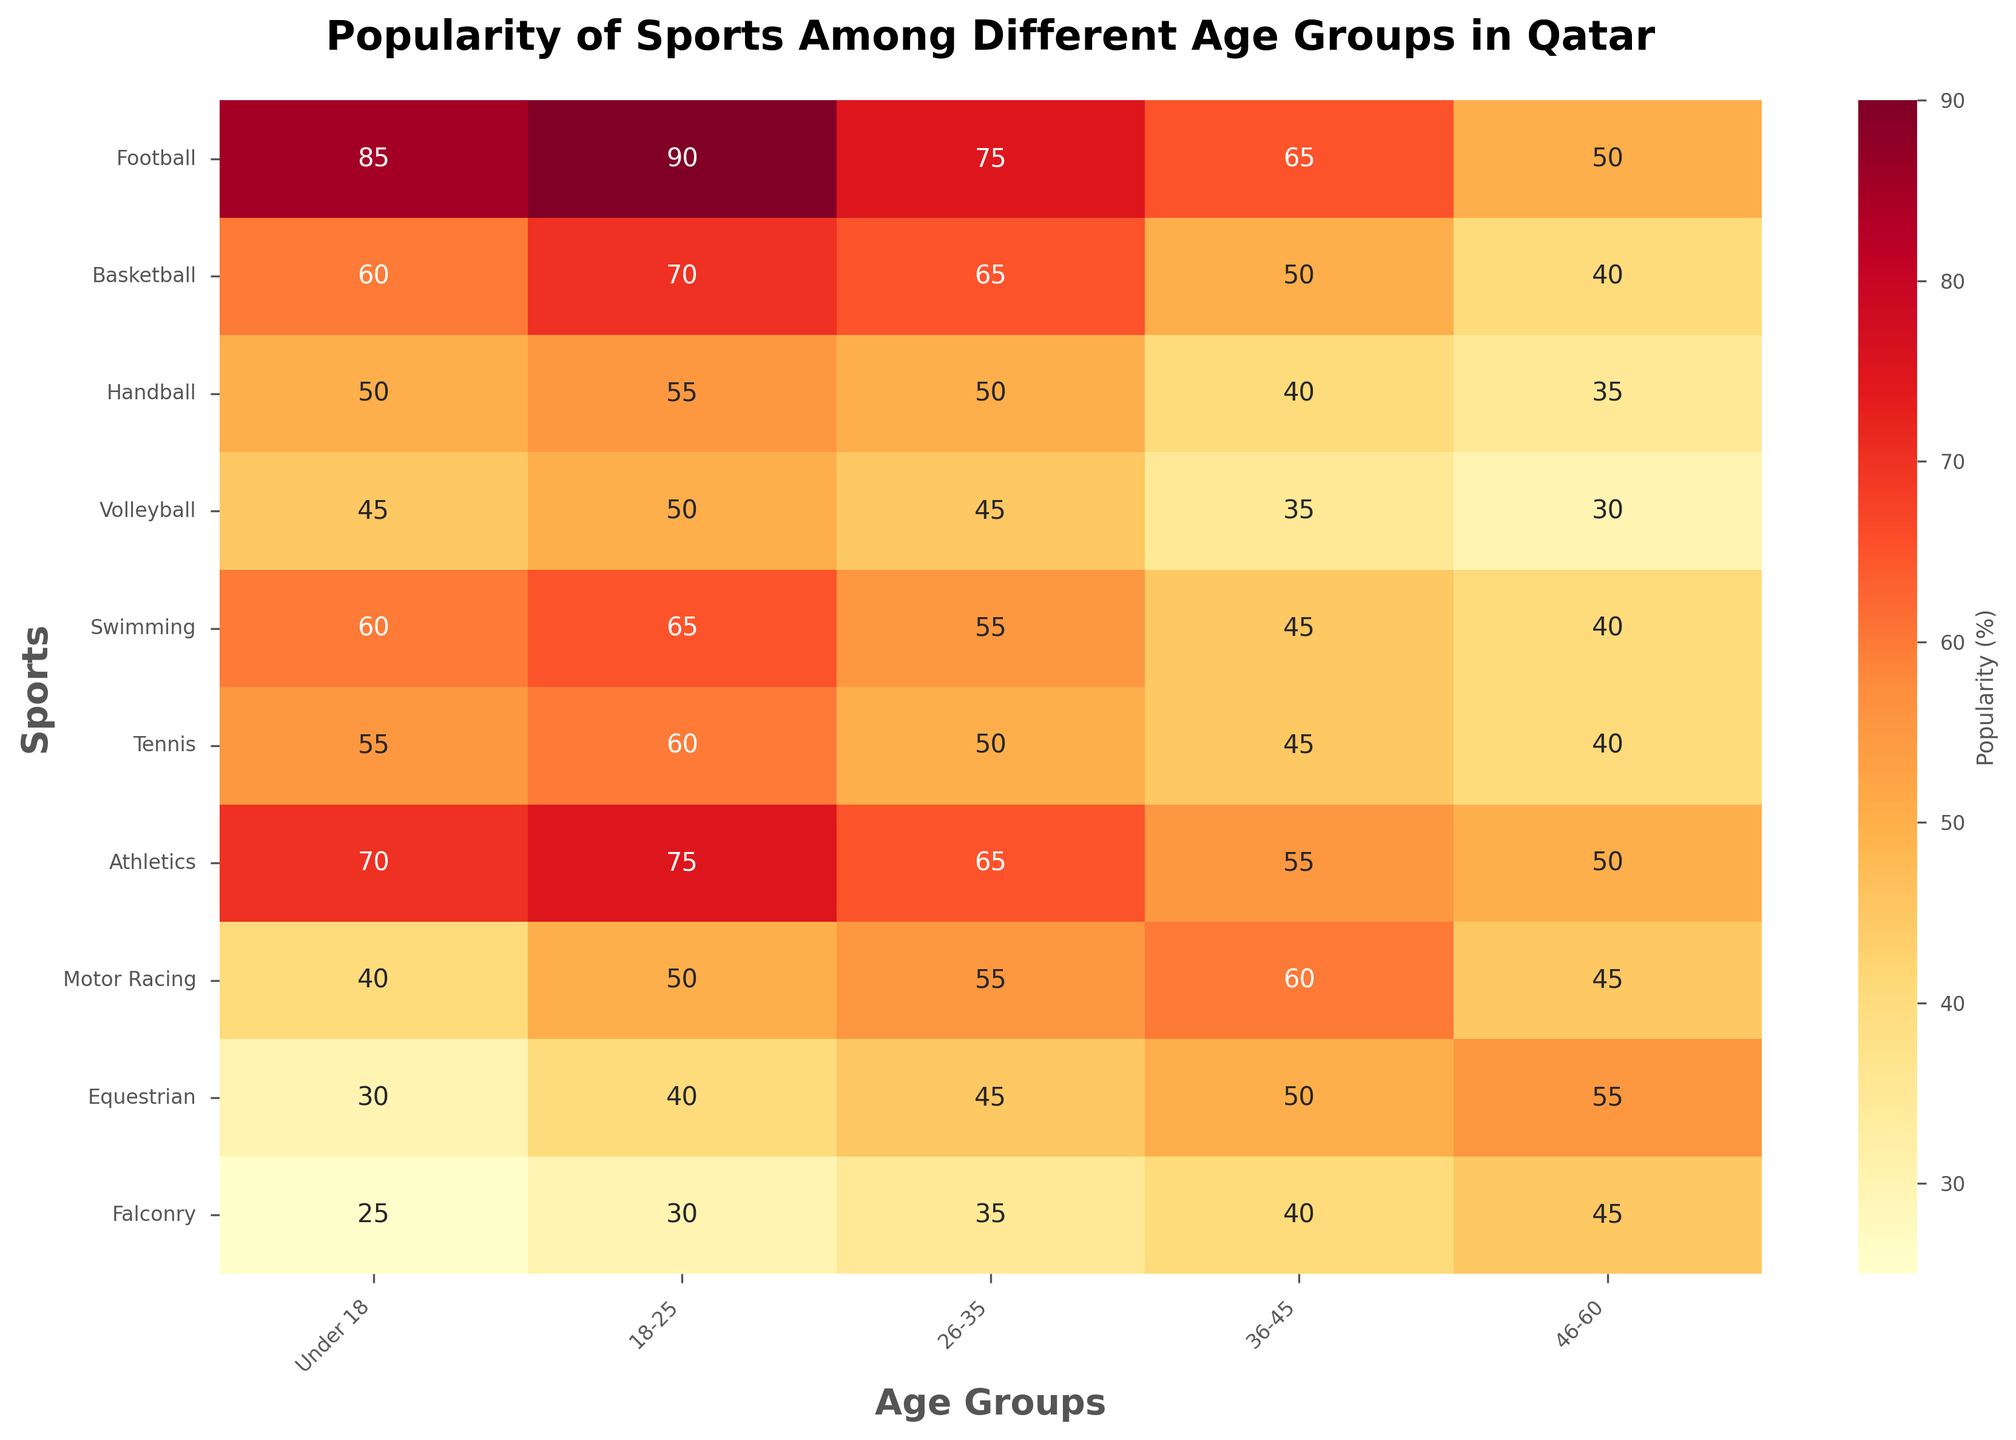Which sport is the most popular among the Under 18 age group? The heatmap shows popularity percentages for different sports by age groups. For the Under 18 age group, look for the highest value. Football has the highest value at 85.
Answer: Football What is the difference in popularity of Motor Racing between the 36-45 and Under 18 age groups? Identify the values for Motor Racing in the respective age groups from the heatmap: 60 for 36-45 and 40 for Under 18. The difference is 60 - 40.
Answer: 20 How does the popularity of Falconry change across the age groups? Observe the values for Falconry across all age groups in the heatmap: 25 (Under 18), 30 (18-25), 35 (26-35), 40 (36-45), and 45 (46-60). The popularity gradually increases as the age group increases.
Answer: Increases Which age group shows the lowest popularity for Tennis? Find the Tennis row and identify the lowest value across the age groups in the heatmap. The lowest value is 50, found in the 26-35 age group.
Answer: 26-35 What is the average popularity of Volleyball across all age groups? Sum the popularity values for Volleyball across all age groups and divide by the number of age groups: (45 + 50 + 45 + 35 + 30)/5 = 205/5.
Answer: 41 Is Swimming more popular among the Under 18 age group or the 46-60 age group? Compare the values of Swimming for Under 18 (60) and 46-60 (40) in the heatmap. Swimming is more popular among the Under 18 age group.
Answer: Under 18 Which two sports have the smallest difference in popularity within the 18-25 age group? Examine the 18-25 column and calculate the differences between each pair of sports. The smallest difference is between Football (90) and Basketball (70): 90 - 70.
Answer: Football and Basketball What trend can be observed in the popularity of Equestrian across the age groups? Look at the values for Equestrian in the heatmap: 30 (Under 18), 40 (18-25), 45 (26-35), 50 (36-45), 55 (46-60). The popularity of Equestrian increases with age.
Answer: Increases How does the popularity of Basketball compare between the 18-25 and 26-35 age groups? Examine the values for Basketball in the 18-25 (70) and 26-35 (65) age groups in the heatmap. Basketball is slightly more popular in the 18-25 age group.
Answer: More popular in 18-25 What is the sum of the popularity values for Football and Athletics in the Under 18 age group? Find the popularity values for Football (85) and Athletics (70) in the Under 18 age group, and sum them: 85 + 70.
Answer: 155 